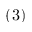Convert formula to latex. <formula><loc_0><loc_0><loc_500><loc_500>( 3 )</formula> 